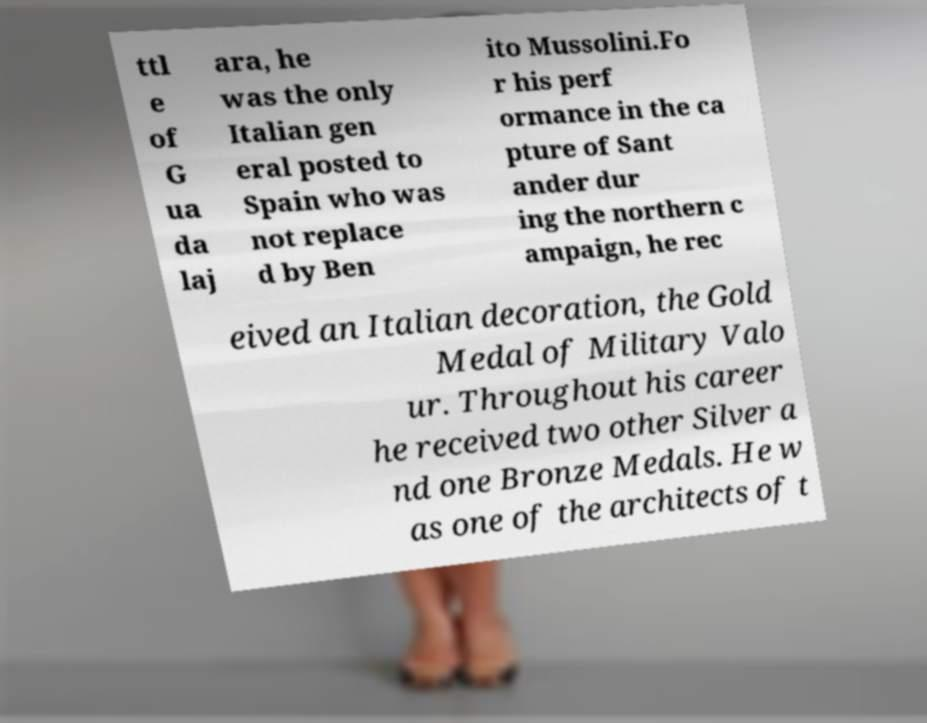Can you accurately transcribe the text from the provided image for me? ttl e of G ua da laj ara, he was the only Italian gen eral posted to Spain who was not replace d by Ben ito Mussolini.Fo r his perf ormance in the ca pture of Sant ander dur ing the northern c ampaign, he rec eived an Italian decoration, the Gold Medal of Military Valo ur. Throughout his career he received two other Silver a nd one Bronze Medals. He w as one of the architects of t 